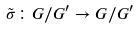<formula> <loc_0><loc_0><loc_500><loc_500>\tilde { \sigma } \colon G / G ^ { \prime } \rightarrow G / G ^ { \prime }</formula> 